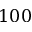Convert formula to latex. <formula><loc_0><loc_0><loc_500><loc_500>1 0 0</formula> 